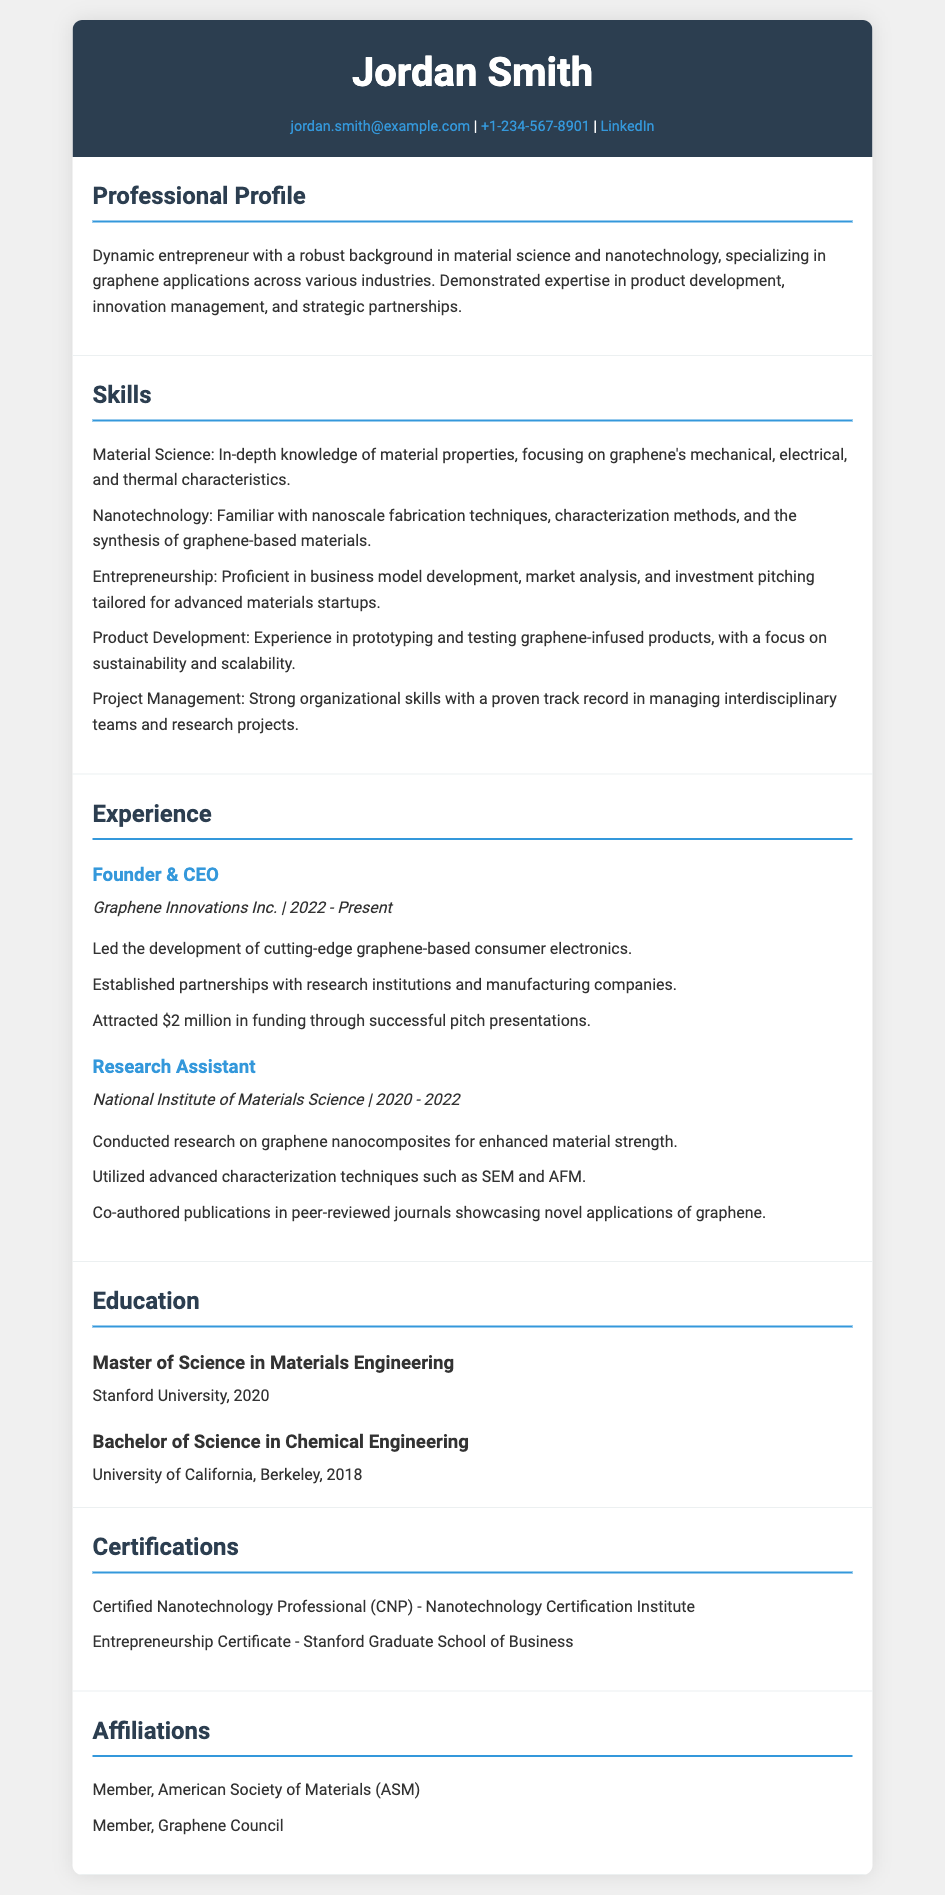What is the name of the individual? The document displays the person's name prominently at the top, which is Jordan Smith.
Answer: Jordan Smith What is the email address provided in the contact info? The resume lists a specific email address under contact info, which is jordan.smith@example.com.
Answer: jordan.smith@example.com What is the highest level of education attained? The highest degree listed in the education section is the Master's degree.
Answer: Master of Science in Materials Engineering How much funding did Graphene Innovations Inc. attract? The amount of funding achieved is explicitly mentioned in the experience section under Graphene Innovations Inc.
Answer: $2 million What certification did Jordan Smith receive related to nanotechnology? The certifications section notes a specific certification related to nanotechnology, which is Certified Nanotechnology Professional.
Answer: Certified Nanotechnology Professional How many years did Jordan Smith work as a Research Assistant? The document specifies the duration of the Research Assistant position held at the National Institute of Materials Science, which is 2 years.
Answer: 2 years What university did Jordan Smith attend for his Bachelor's degree? The education section indicates the institution for the Bachelor's degree, the University of California, Berkeley.
Answer: University of California, Berkeley What specific skills are mentioned related to product development? The skills section details specific skills in product development, emphasizing prototyping and testing of graphene-infused products.
Answer: Prototyping and testing graphene-infused products In which year was Graphene Innovations Inc. founded? The experience section indicates the starting year of Graphene Innovations Inc., which is 2022.
Answer: 2022 